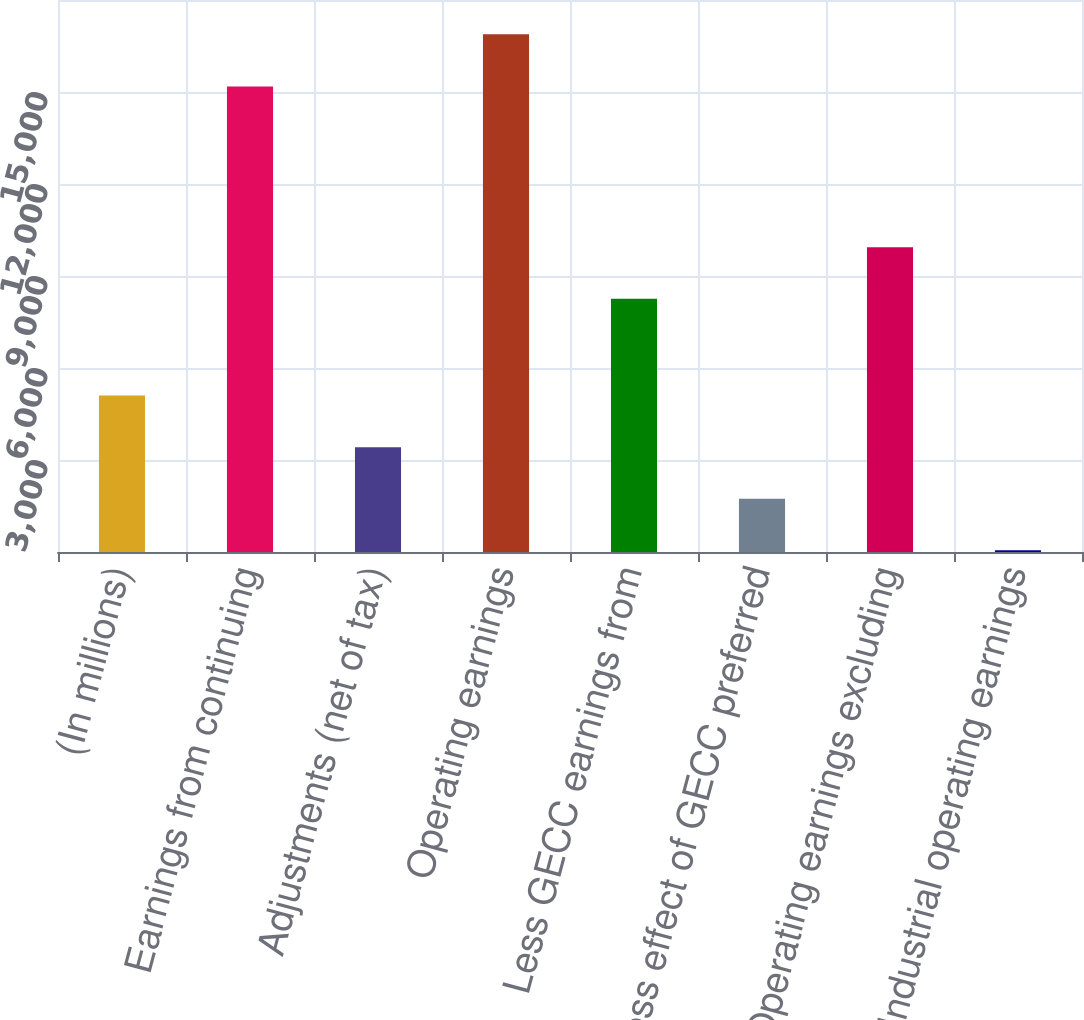<chart> <loc_0><loc_0><loc_500><loc_500><bar_chart><fcel>(In millions)<fcel>Earnings from continuing<fcel>Adjustments (net of tax)<fcel>Operating earnings<fcel>Less GECC earnings from<fcel>Less effect of GECC preferred<fcel>Operating earnings excluding<fcel>Industrial operating earnings<nl><fcel>5101.7<fcel>15177<fcel>3418.8<fcel>16882<fcel>8258<fcel>1735.9<fcel>9940.9<fcel>53<nl></chart> 